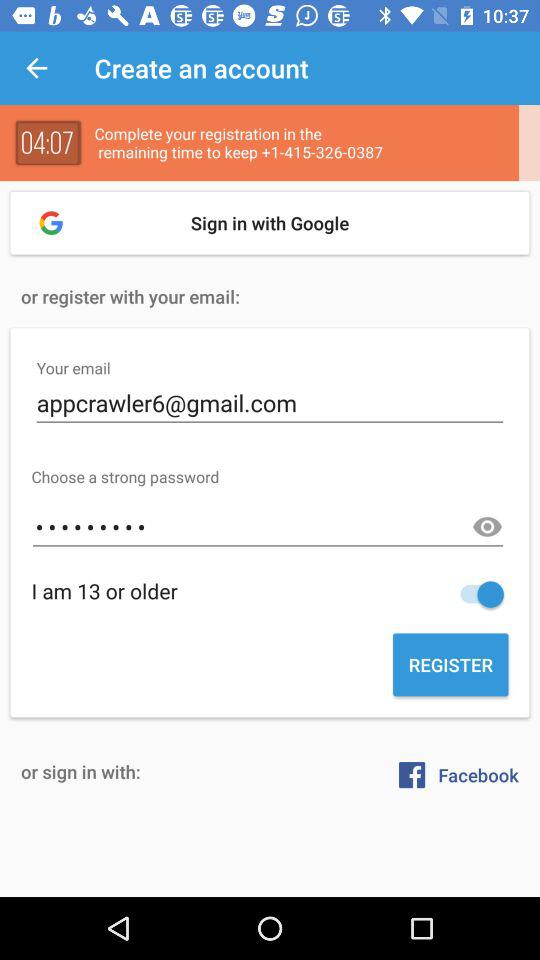How much time do I have left for registration? You have 4 minutes and 7 seconds left for registration. 